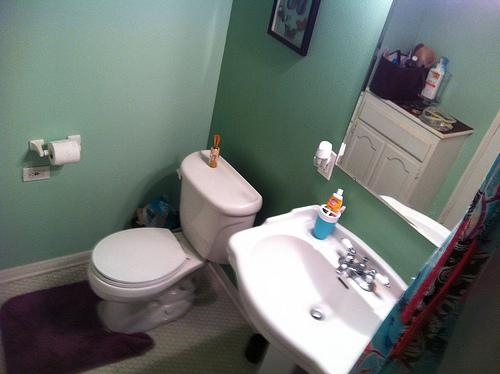Question: where is the picture taken?
Choices:
A. Bedroom.
B. Bathroom.
C. Kitchen.
D. Den.
Answer with the letter. Answer: B Question: what is in the frame above the toilet?
Choices:
A. Seashells.
B. People.
C. Butterflies.
D. Flowers.
Answer with the letter. Answer: C Question: what color is the rug?
Choices:
A. Pink.
B. Blue.
C. Green.
D. Purple.
Answer with the letter. Answer: D Question: where is the toilet paper?
Choices:
A. On the floor.
B. Above the outlet.
C. On the toilet.
D. In the trash.
Answer with the letter. Answer: B Question: how many electrical outlets?
Choices:
A. 2.
B. 1.
C. 3.
D. 4.
Answer with the letter. Answer: A 